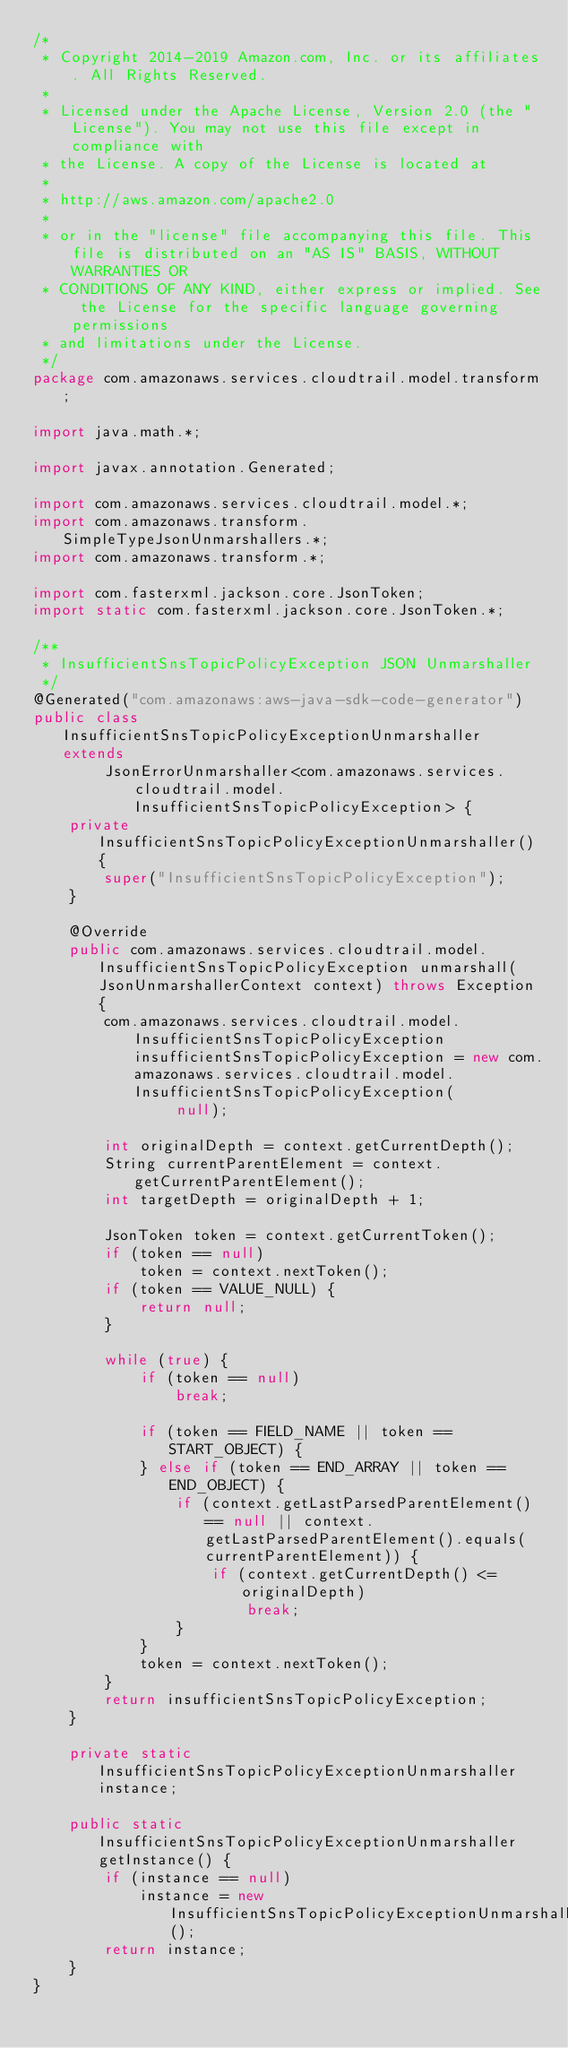<code> <loc_0><loc_0><loc_500><loc_500><_Java_>/*
 * Copyright 2014-2019 Amazon.com, Inc. or its affiliates. All Rights Reserved.
 * 
 * Licensed under the Apache License, Version 2.0 (the "License"). You may not use this file except in compliance with
 * the License. A copy of the License is located at
 * 
 * http://aws.amazon.com/apache2.0
 * 
 * or in the "license" file accompanying this file. This file is distributed on an "AS IS" BASIS, WITHOUT WARRANTIES OR
 * CONDITIONS OF ANY KIND, either express or implied. See the License for the specific language governing permissions
 * and limitations under the License.
 */
package com.amazonaws.services.cloudtrail.model.transform;

import java.math.*;

import javax.annotation.Generated;

import com.amazonaws.services.cloudtrail.model.*;
import com.amazonaws.transform.SimpleTypeJsonUnmarshallers.*;
import com.amazonaws.transform.*;

import com.fasterxml.jackson.core.JsonToken;
import static com.fasterxml.jackson.core.JsonToken.*;

/**
 * InsufficientSnsTopicPolicyException JSON Unmarshaller
 */
@Generated("com.amazonaws:aws-java-sdk-code-generator")
public class InsufficientSnsTopicPolicyExceptionUnmarshaller extends
        JsonErrorUnmarshaller<com.amazonaws.services.cloudtrail.model.InsufficientSnsTopicPolicyException> {
    private InsufficientSnsTopicPolicyExceptionUnmarshaller() {
        super("InsufficientSnsTopicPolicyException");
    }

    @Override
    public com.amazonaws.services.cloudtrail.model.InsufficientSnsTopicPolicyException unmarshall(JsonUnmarshallerContext context) throws Exception {
        com.amazonaws.services.cloudtrail.model.InsufficientSnsTopicPolicyException insufficientSnsTopicPolicyException = new com.amazonaws.services.cloudtrail.model.InsufficientSnsTopicPolicyException(
                null);

        int originalDepth = context.getCurrentDepth();
        String currentParentElement = context.getCurrentParentElement();
        int targetDepth = originalDepth + 1;

        JsonToken token = context.getCurrentToken();
        if (token == null)
            token = context.nextToken();
        if (token == VALUE_NULL) {
            return null;
        }

        while (true) {
            if (token == null)
                break;

            if (token == FIELD_NAME || token == START_OBJECT) {
            } else if (token == END_ARRAY || token == END_OBJECT) {
                if (context.getLastParsedParentElement() == null || context.getLastParsedParentElement().equals(currentParentElement)) {
                    if (context.getCurrentDepth() <= originalDepth)
                        break;
                }
            }
            token = context.nextToken();
        }
        return insufficientSnsTopicPolicyException;
    }

    private static InsufficientSnsTopicPolicyExceptionUnmarshaller instance;

    public static InsufficientSnsTopicPolicyExceptionUnmarshaller getInstance() {
        if (instance == null)
            instance = new InsufficientSnsTopicPolicyExceptionUnmarshaller();
        return instance;
    }
}
</code> 